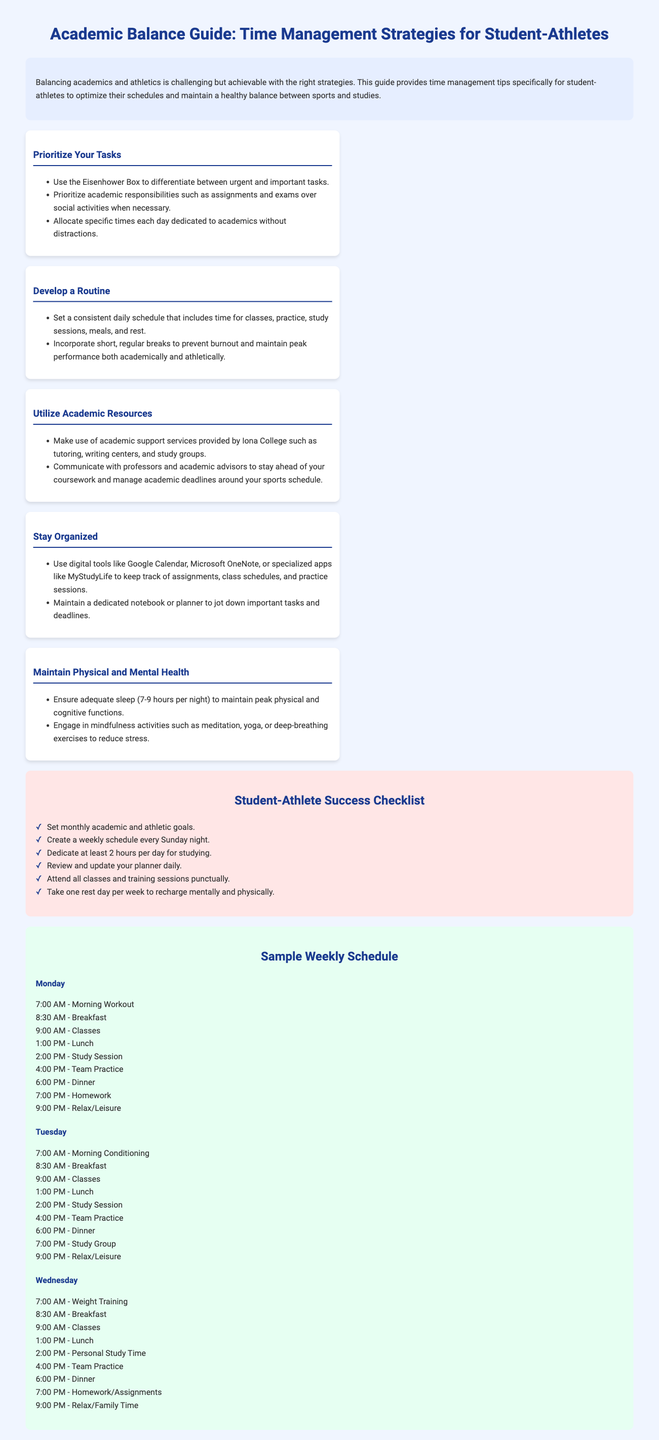what is the title of the guide? The title is stated at the top of the document, encapsulating the main theme of the content.
Answer: Academic Balance Guide: Time Management Strategies for Student-Athletes how many hours per night is recommended for sleep? The document specifies the amount of sleep needed for optimal performance, both physically and cognitively.
Answer: 7-9 hours what is one tool suggested for staying organized? The document provides examples of digital tools that can help in maintaining organization for student-athletes.
Answer: Google Calendar what is the first step in prioritizing tasks? The guide outlines an initial method for managing task priorities effectively.
Answer: Use the Eisenhower Box how many rest days per week are recommended? The checklist states the importance of taking breaks to recharge physically and mentally.
Answer: One rest day what is the time allocated for personal study on Wednesday? The document includes specific time slots for different activities throughout the week.
Answer: 2:00 PM what is the main focus of the "Develop a Routine" section? This section emphasizes the importance of having a structured schedule for success.
Answer: Consistent daily schedule how many study hours are suggested each day? The checklist suggests a specific number of hours dedicated to studying each day.
Answer: At least 2 hours what should be attended punctually according to the checklist? The checklist emphasizes the importance of attendance for both classes and training.
Answer: All classes and training sessions 